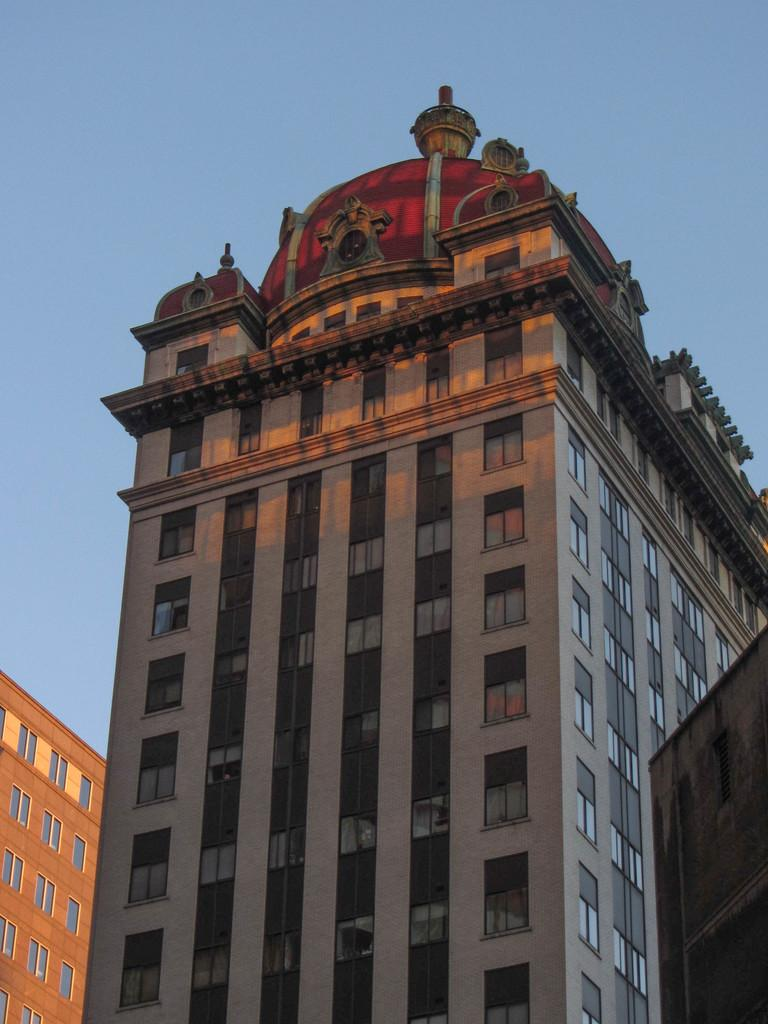What type of structures are present in the image? There are buildings in the image. What feature can be seen on the buildings? The buildings have windows. What can be seen in the background of the image? The sky is visible in the background of the image. What type of whip can be seen in the image? There is no whip present in the image. How does the behavior of the buildings change throughout the day in the image? The behavior of the buildings does not change throughout the day in the image, as they are inanimate structures. 